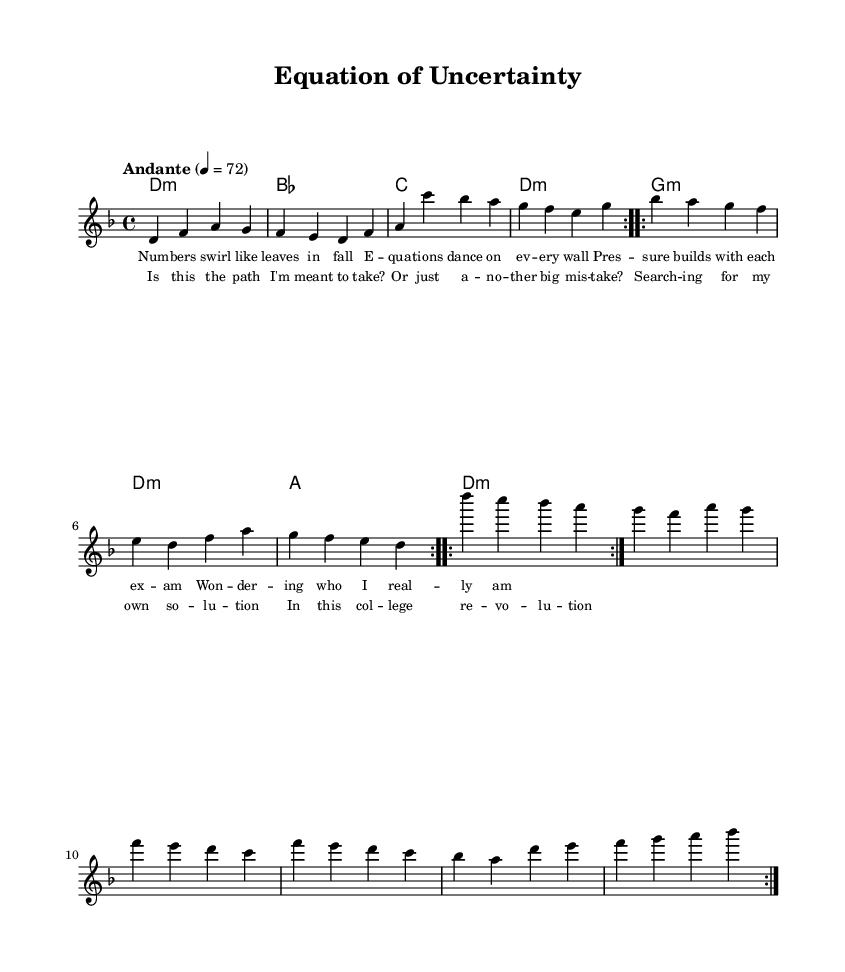What is the key signature of this music? The key signature is indicated at the beginning of the staff. It shows one flat, which corresponds to D minor.
Answer: D minor What is the time signature of this music? The time signature is displayed after the key signature at the beginning of the score. It is noted as 4/4, which means there are four beats in each measure.
Answer: 4/4 What is the tempo marking of this piece? The tempo marking is specified at the start of the score and is indicated as "Andante" with a metronome mark of 4 = 72. This suggests a moderate pace.
Answer: Andante How many measures are in the chorus? The chorus section can be counted based on the number of lines where lyrics are set in the sheet music. There are four lines, indicating four measures of lyrics.
Answer: 4 What type of chord is used in the first measure of the harmonies? The first measure's chord is annotated as D minor, which is reflected in the chord names in the harmonies section.
Answer: D:m How many volta sections are indicated in the melody? The notation specifies "repeat volta 2" twice in the melody section, indicating that there are two volta sections present.
Answer: 2 What thematic aspect is expressed in the lyrics of the chorus? The lyrics explore self-discovery and the pressure of making choices in college, suggesting a personal reflection and uncertainty about life's paths.
Answer: Personal reflection 